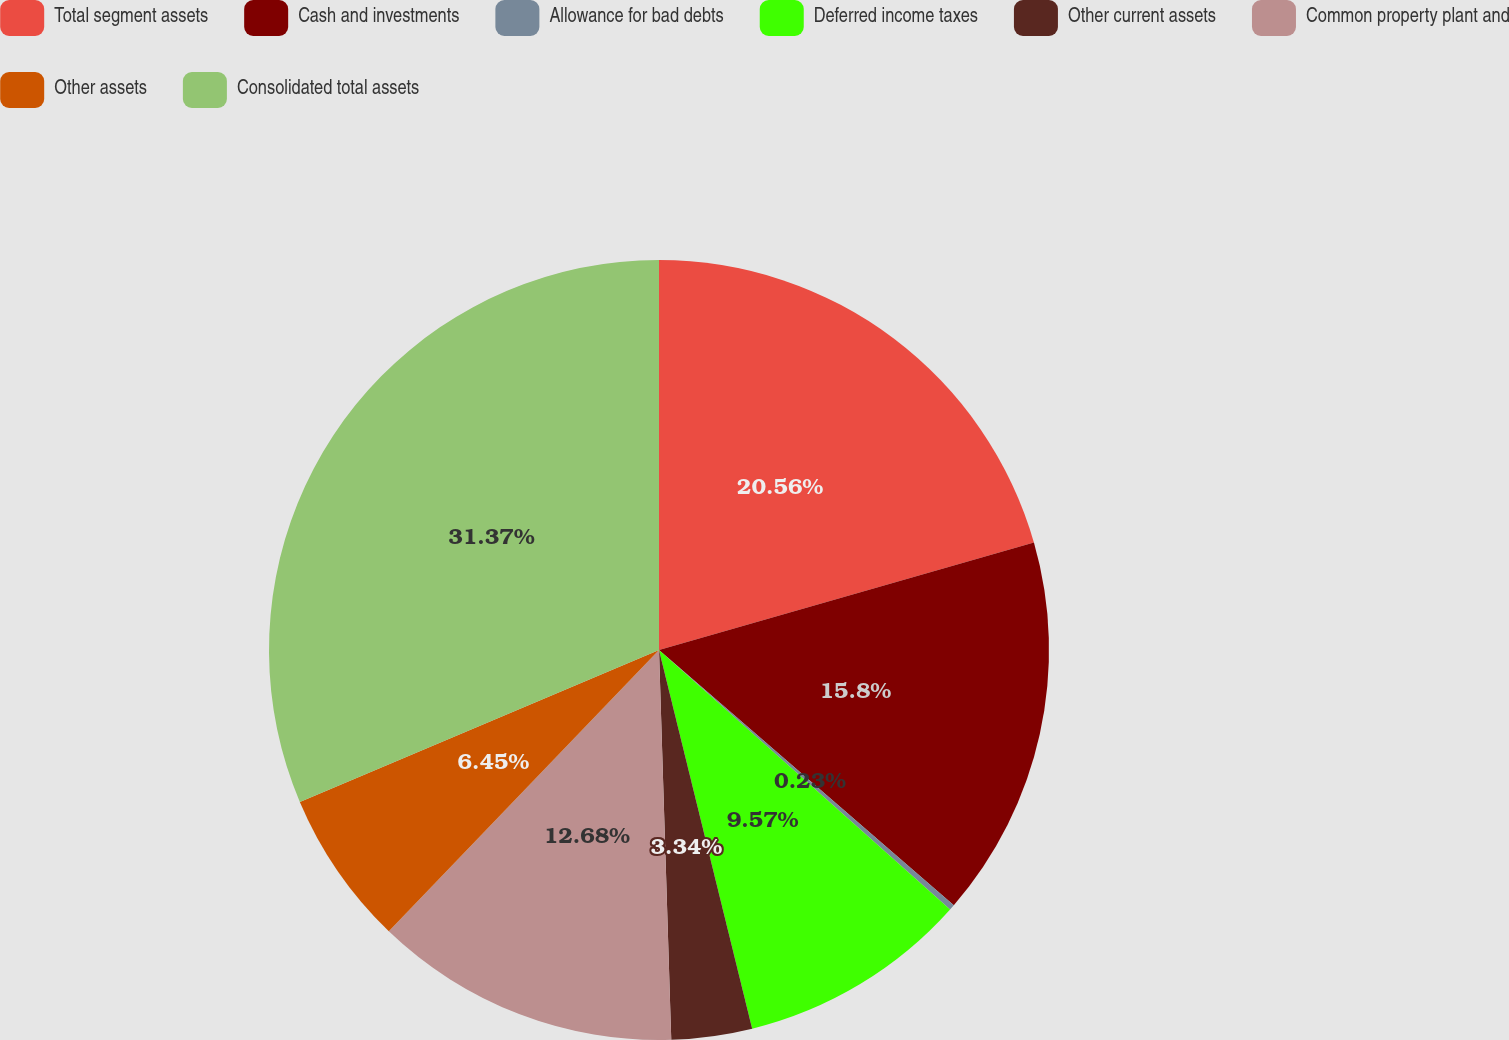Convert chart to OTSL. <chart><loc_0><loc_0><loc_500><loc_500><pie_chart><fcel>Total segment assets<fcel>Cash and investments<fcel>Allowance for bad debts<fcel>Deferred income taxes<fcel>Other current assets<fcel>Common property plant and<fcel>Other assets<fcel>Consolidated total assets<nl><fcel>20.56%<fcel>15.8%<fcel>0.23%<fcel>9.57%<fcel>3.34%<fcel>12.68%<fcel>6.45%<fcel>31.37%<nl></chart> 